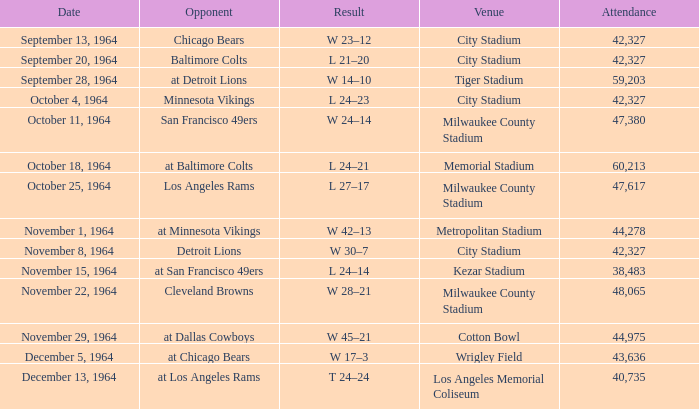What is the average week of the game on November 22, 1964 attended by 48,065? None. 